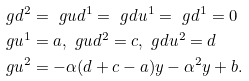Convert formula to latex. <formula><loc_0><loc_0><loc_500><loc_500>\ g d ^ { 2 } & = \ g u d ^ { 1 } = \ g d u ^ { 1 } = \ g d ^ { 1 } = 0 \\ \ g u ^ { 1 } & = a , \ g u d ^ { 2 } = c , \ g d u ^ { 2 } = d \\ \ g u ^ { 2 } & = - \alpha ( d + c - a ) y - \alpha ^ { 2 } y + b .</formula> 